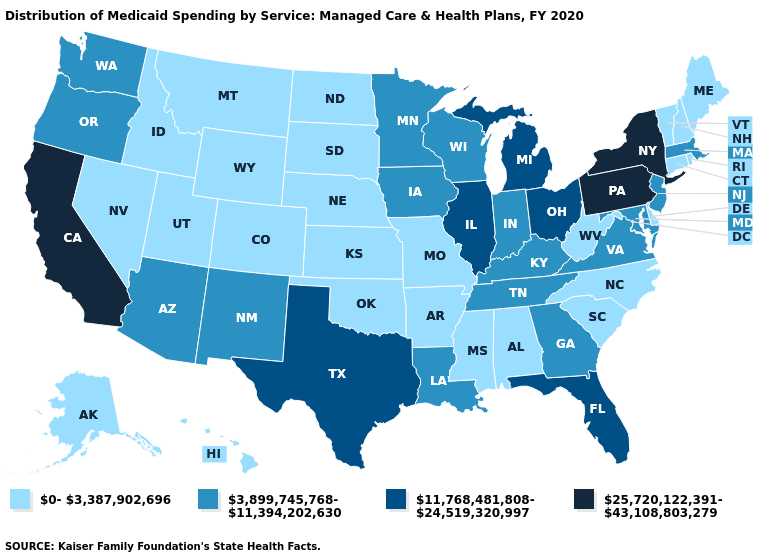What is the value of South Dakota?
Concise answer only. 0-3,387,902,696. Among the states that border Massachusetts , which have the highest value?
Short answer required. New York. Does the map have missing data?
Quick response, please. No. What is the value of Minnesota?
Short answer required. 3,899,745,768-11,394,202,630. Which states have the lowest value in the USA?
Short answer required. Alabama, Alaska, Arkansas, Colorado, Connecticut, Delaware, Hawaii, Idaho, Kansas, Maine, Mississippi, Missouri, Montana, Nebraska, Nevada, New Hampshire, North Carolina, North Dakota, Oklahoma, Rhode Island, South Carolina, South Dakota, Utah, Vermont, West Virginia, Wyoming. What is the value of Arkansas?
Quick response, please. 0-3,387,902,696. Name the states that have a value in the range 25,720,122,391-43,108,803,279?
Concise answer only. California, New York, Pennsylvania. Does South Dakota have a lower value than Mississippi?
Keep it brief. No. What is the value of Colorado?
Give a very brief answer. 0-3,387,902,696. Among the states that border Utah , which have the lowest value?
Short answer required. Colorado, Idaho, Nevada, Wyoming. How many symbols are there in the legend?
Concise answer only. 4. Name the states that have a value in the range 3,899,745,768-11,394,202,630?
Give a very brief answer. Arizona, Georgia, Indiana, Iowa, Kentucky, Louisiana, Maryland, Massachusetts, Minnesota, New Jersey, New Mexico, Oregon, Tennessee, Virginia, Washington, Wisconsin. How many symbols are there in the legend?
Be succinct. 4. Among the states that border Maryland , which have the highest value?
Answer briefly. Pennsylvania. Does New Mexico have the lowest value in the West?
Write a very short answer. No. 